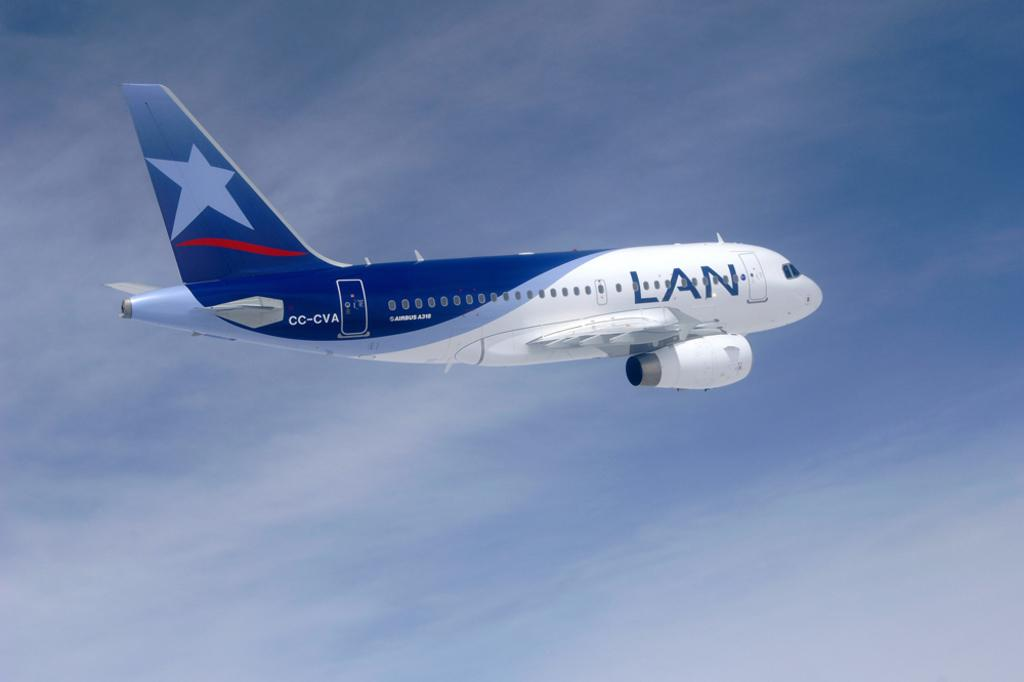Where was the picture taken? The picture was clicked outside. What can be seen in the sky in the image? There is an airplane flying in the sky. What is written or displayed on the airplane? The airplane has text on it. What is visible in the background of the image? The sky is visible in the background of the image. What type of metal can be seen rusting on the ground in the image? There is no metal or rust visible on the ground in the image; it only features an airplane flying in the sky. 